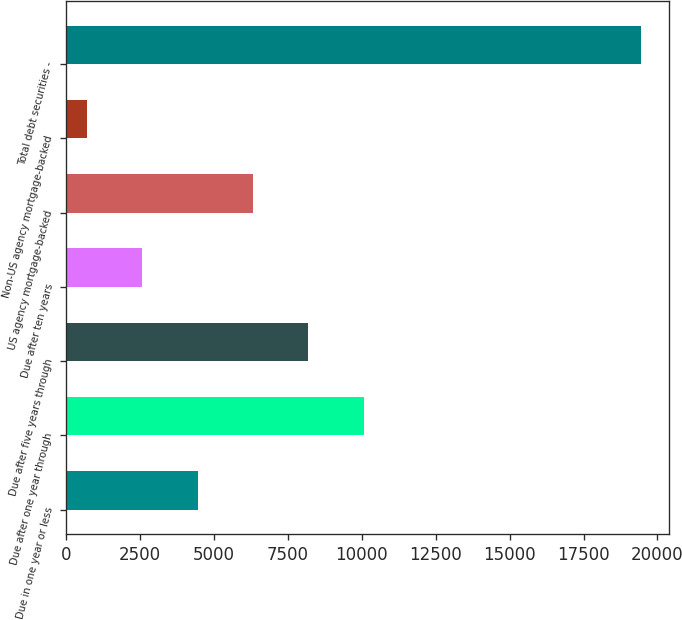Convert chart. <chart><loc_0><loc_0><loc_500><loc_500><bar_chart><fcel>Due in one year or less<fcel>Due after one year through<fcel>Due after five years through<fcel>Due after ten years<fcel>US agency mortgage-backed<fcel>Non-US agency mortgage-backed<fcel>Total debt securities -<nl><fcel>4447<fcel>10064.5<fcel>8192<fcel>2574.5<fcel>6319.5<fcel>702<fcel>19427<nl></chart> 